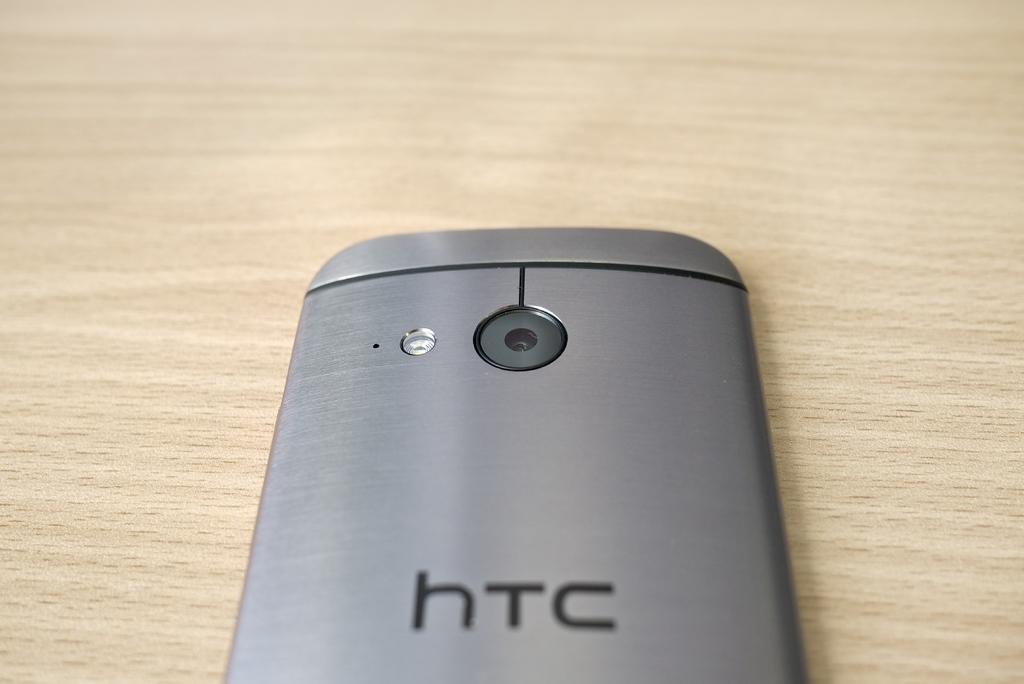Provide a one-sentence caption for the provided image. the back of an HTC silver phone on a wooden surface. 